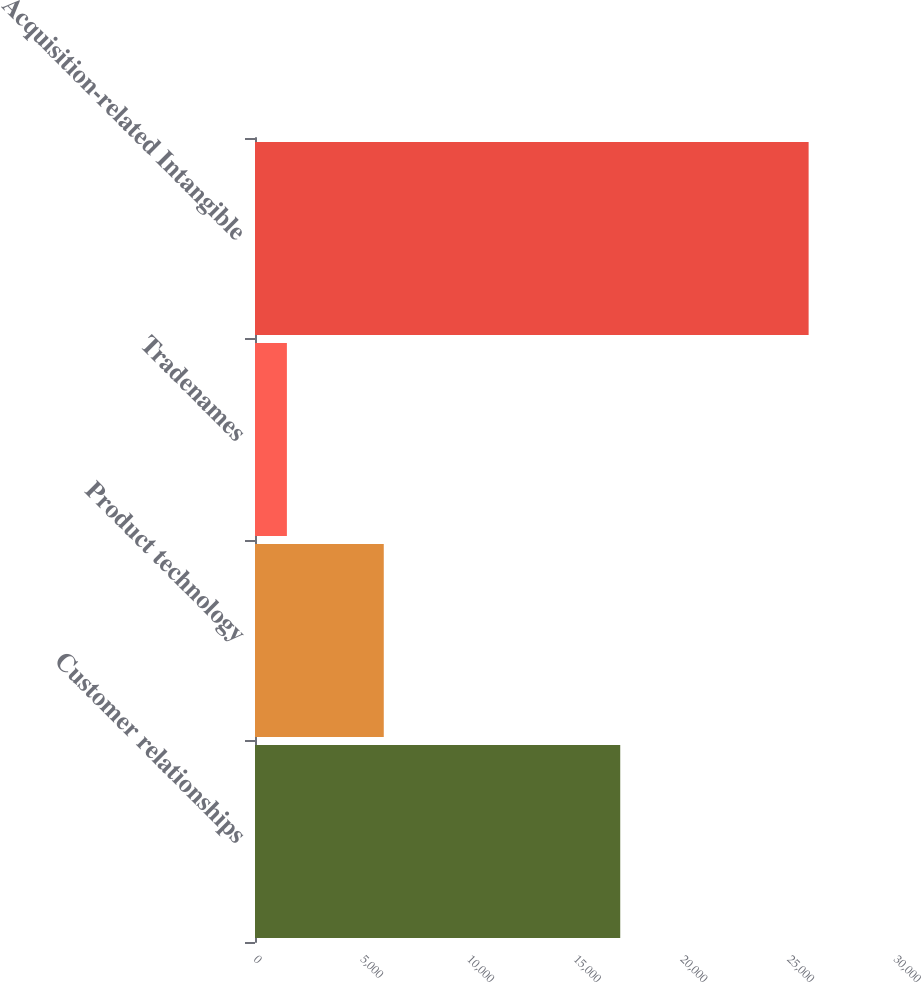Convert chart. <chart><loc_0><loc_0><loc_500><loc_500><bar_chart><fcel>Customer relationships<fcel>Product technology<fcel>Tradenames<fcel>Acquisition-related Intangible<nl><fcel>17120<fcel>6036<fcel>1495<fcel>25951<nl></chart> 